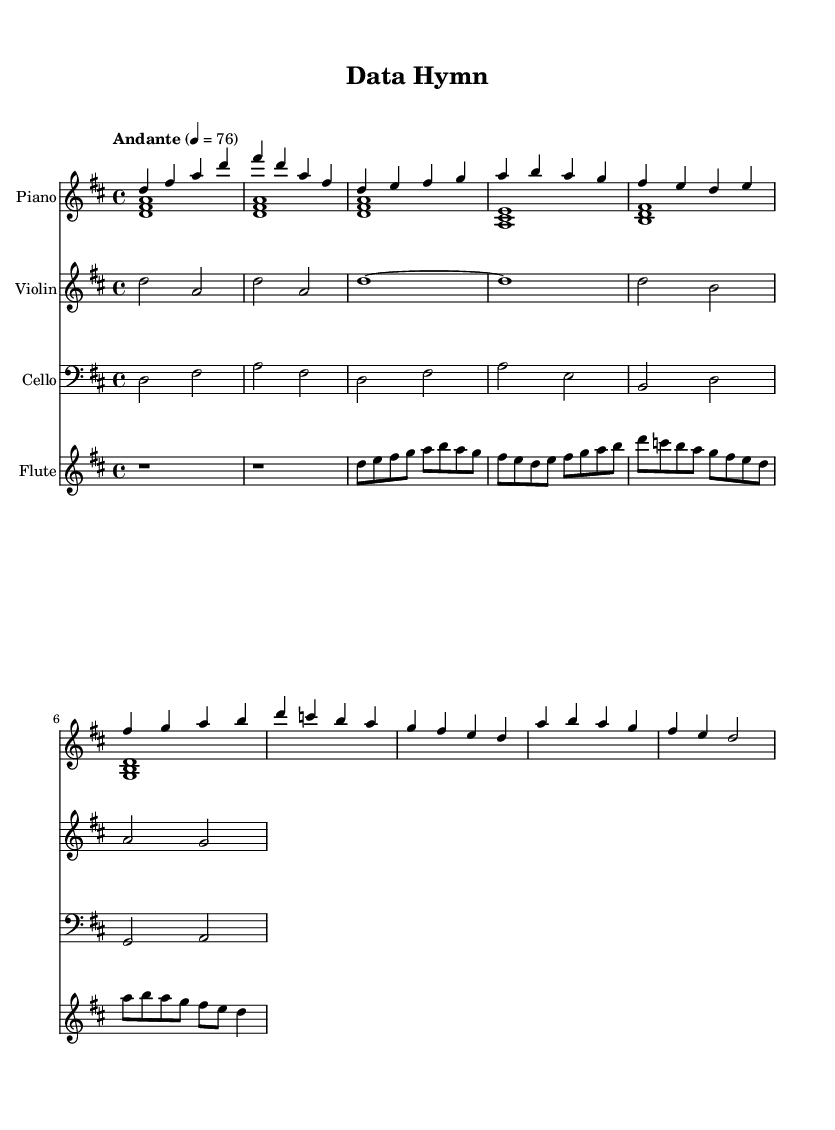What is the key signature of this music? The key signature is D major, which has two sharps (F# and C#).
Answer: D major What is the time signature of this piece? The time signature is 4/4, indicating four beats per measure.
Answer: 4/4 What is the tempo marking for this music? The tempo marking is "Andante" with a metronome setting of 76 beats per minute.
Answer: Andante How many measures are in the Intro section? There are 2 measures in the Intro section of the music.
Answer: 2 What is the melody instrument in this piece? The melody instrument in this piece is the Violin, as it plays the main melodic line.
Answer: Violin How does the dynamic change in the transition from the Verse to the Chorus? The dynamics generally increase in the transition from the Verse to the Chorus, indicating a more expressive playing style.
Answer: Increase What role does the cello play in this composition? The cello plays a harmonic and supportive role, providing a bass foundation beneath the higher instruments.
Answer: Supportive 